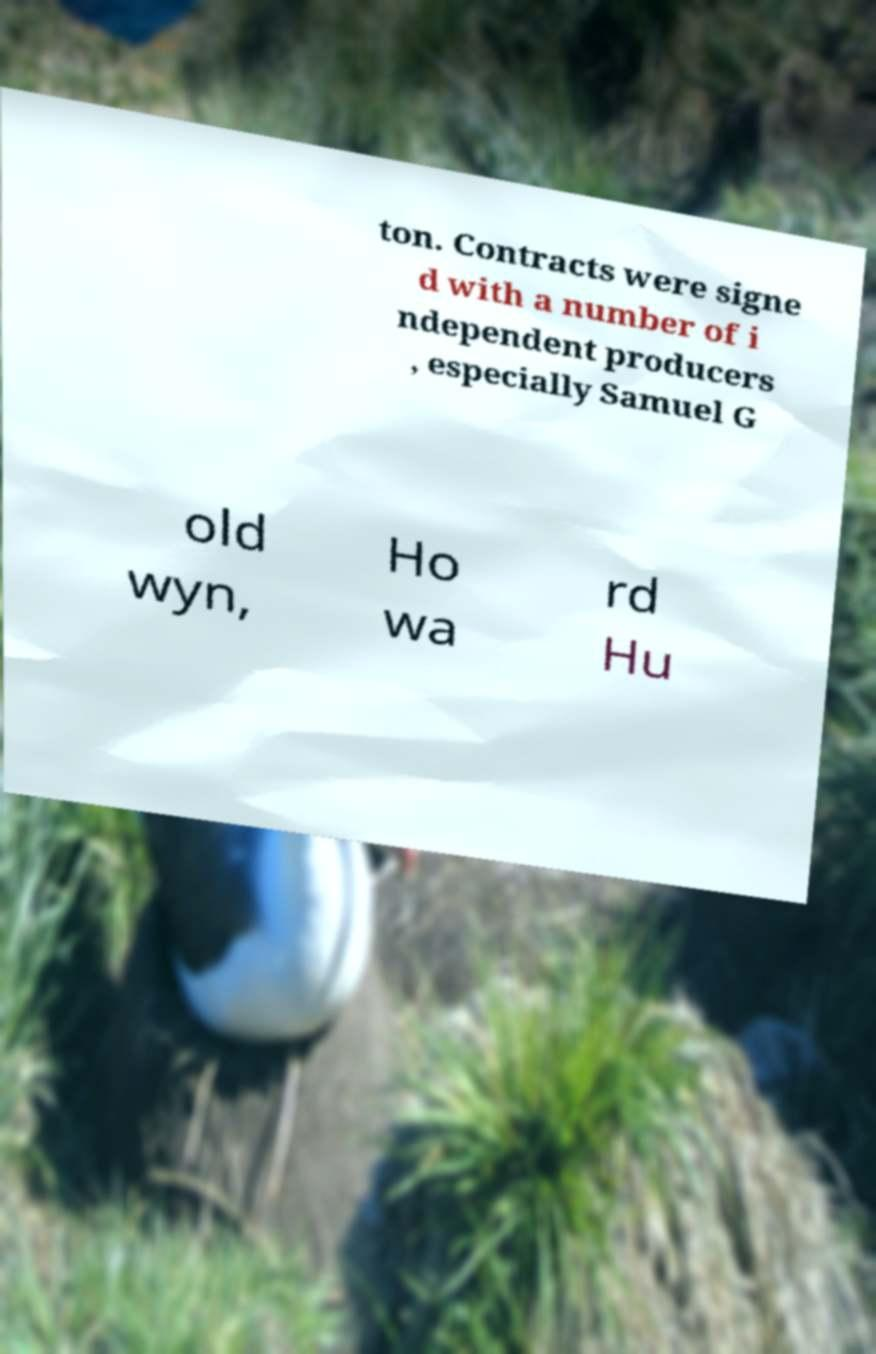What messages or text are displayed in this image? I need them in a readable, typed format. ton. Contracts were signe d with a number of i ndependent producers , especially Samuel G old wyn, Ho wa rd Hu 